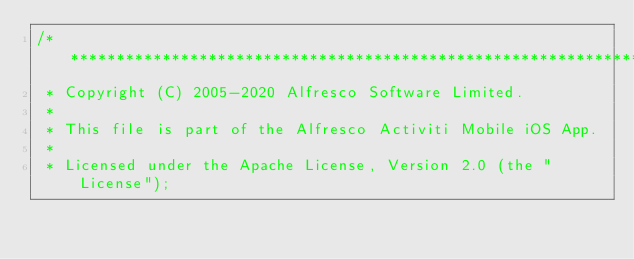Convert code to text. <code><loc_0><loc_0><loc_500><loc_500><_C_>/*******************************************************************************
 * Copyright (C) 2005-2020 Alfresco Software Limited.
 *
 * This file is part of the Alfresco Activiti Mobile iOS App.
 *
 * Licensed under the Apache License, Version 2.0 (the "License");</code> 